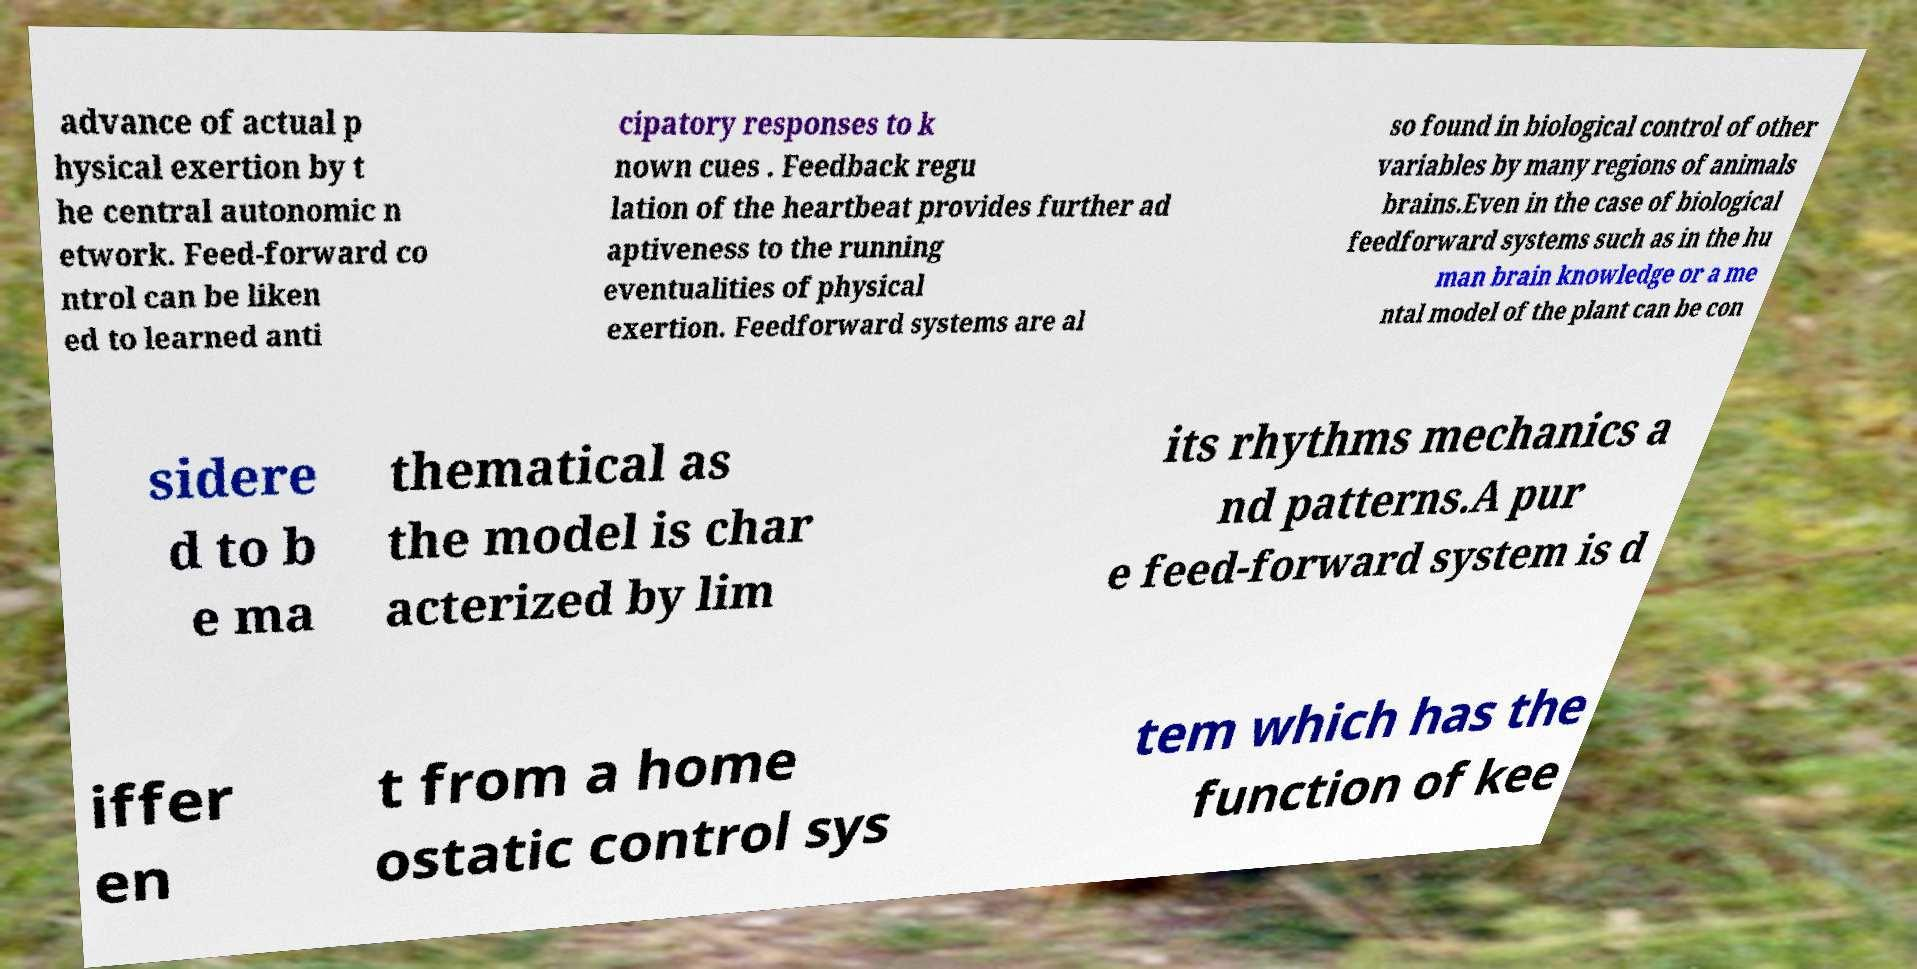Please read and relay the text visible in this image. What does it say? advance of actual p hysical exertion by t he central autonomic n etwork. Feed-forward co ntrol can be liken ed to learned anti cipatory responses to k nown cues . Feedback regu lation of the heartbeat provides further ad aptiveness to the running eventualities of physical exertion. Feedforward systems are al so found in biological control of other variables by many regions of animals brains.Even in the case of biological feedforward systems such as in the hu man brain knowledge or a me ntal model of the plant can be con sidere d to b e ma thematical as the model is char acterized by lim its rhythms mechanics a nd patterns.A pur e feed-forward system is d iffer en t from a home ostatic control sys tem which has the function of kee 